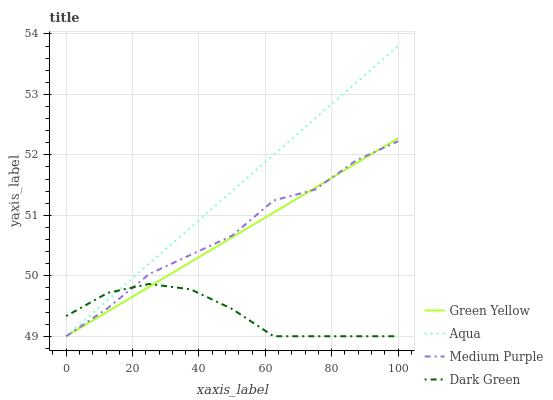Does Dark Green have the minimum area under the curve?
Answer yes or no. Yes. Does Aqua have the maximum area under the curve?
Answer yes or no. Yes. Does Green Yellow have the minimum area under the curve?
Answer yes or no. No. Does Green Yellow have the maximum area under the curve?
Answer yes or no. No. Is Green Yellow the smoothest?
Answer yes or no. Yes. Is Medium Purple the roughest?
Answer yes or no. Yes. Is Aqua the smoothest?
Answer yes or no. No. Is Aqua the roughest?
Answer yes or no. No. Does Medium Purple have the lowest value?
Answer yes or no. Yes. Does Aqua have the highest value?
Answer yes or no. Yes. Does Green Yellow have the highest value?
Answer yes or no. No. Does Dark Green intersect Medium Purple?
Answer yes or no. Yes. Is Dark Green less than Medium Purple?
Answer yes or no. No. Is Dark Green greater than Medium Purple?
Answer yes or no. No. 